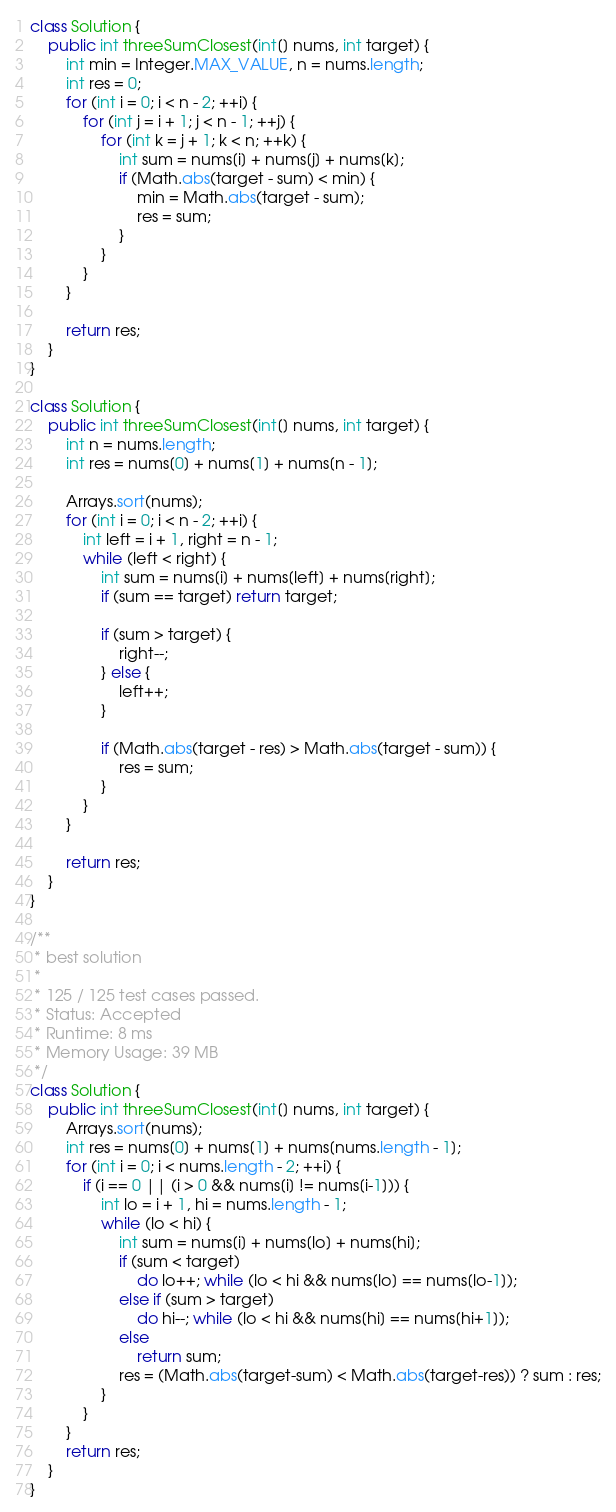Convert code to text. <code><loc_0><loc_0><loc_500><loc_500><_Java_>class Solution {
    public int threeSumClosest(int[] nums, int target) {
        int min = Integer.MAX_VALUE, n = nums.length;
        int res = 0;
        for (int i = 0; i < n - 2; ++i) {
            for (int j = i + 1; j < n - 1; ++j) {
                for (int k = j + 1; k < n; ++k) {
                    int sum = nums[i] + nums[j] + nums[k];
                    if (Math.abs(target - sum) < min) {
                        min = Math.abs(target - sum);
                        res = sum;
                    }
                }
            }
        }
        
        return res;
    }
}

class Solution {
    public int threeSumClosest(int[] nums, int target) {
        int n = nums.length;
        int res = nums[0] + nums[1] + nums[n - 1];
        
        Arrays.sort(nums);
        for (int i = 0; i < n - 2; ++i) {
            int left = i + 1, right = n - 1;
            while (left < right) {
                int sum = nums[i] + nums[left] + nums[right];
                if (sum == target) return target;
                
                if (sum > target) {
                    right--;
                } else {
                    left++;     
                }
                
                if (Math.abs(target - res) > Math.abs(target - sum)) {
                    res = sum;
                }    
            }
        }
        
        return res;
    }
}

/**
 * best solution    
 * 
 * 125 / 125 test cases passed.
 * Status: Accepted
 * Runtime: 8 ms
 * Memory Usage: 39 MB
 */
class Solution {
    public int threeSumClosest(int[] nums, int target) {
        Arrays.sort(nums);
        int res = nums[0] + nums[1] + nums[nums.length - 1];
        for (int i = 0; i < nums.length - 2; ++i) {
            if (i == 0 || (i > 0 && nums[i] != nums[i-1])) {
                int lo = i + 1, hi = nums.length - 1;
                while (lo < hi) {
                    int sum = nums[i] + nums[lo] + nums[hi];
                    if (sum < target) 
                        do lo++; while (lo < hi && nums[lo] == nums[lo-1]);
                    else if (sum > target) 
                        do hi--; while (lo < hi && nums[hi] == nums[hi+1]);
                    else 
                        return sum;
                    res = (Math.abs(target-sum) < Math.abs(target-res)) ? sum : res;
                } 
            }
        }   
        return res;
    }
}</code> 